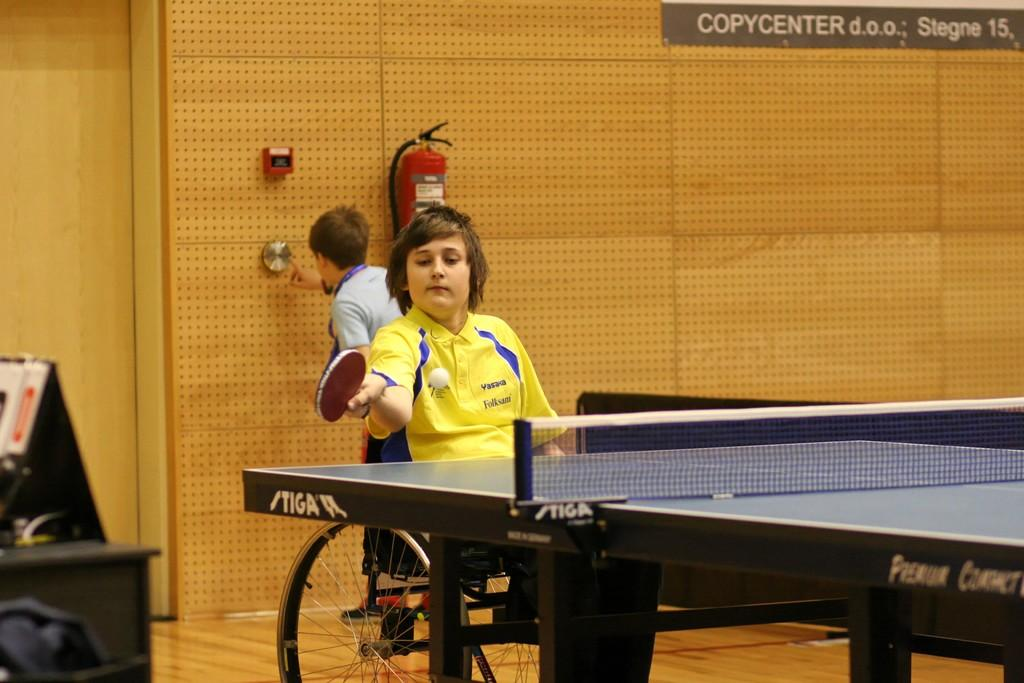What activity is the man in the image engaged in? There is a man playing table tennis in the image. Who else is present in the image? There is another man behind the player, watching. What can be seen on the wall in the image? There is a wall in the image, and a fire extinguisher is present on the wall. What type of milk is being used to play table tennis in the image? There is no milk present in the image; the man is playing table tennis with a table tennis paddle and ball. 